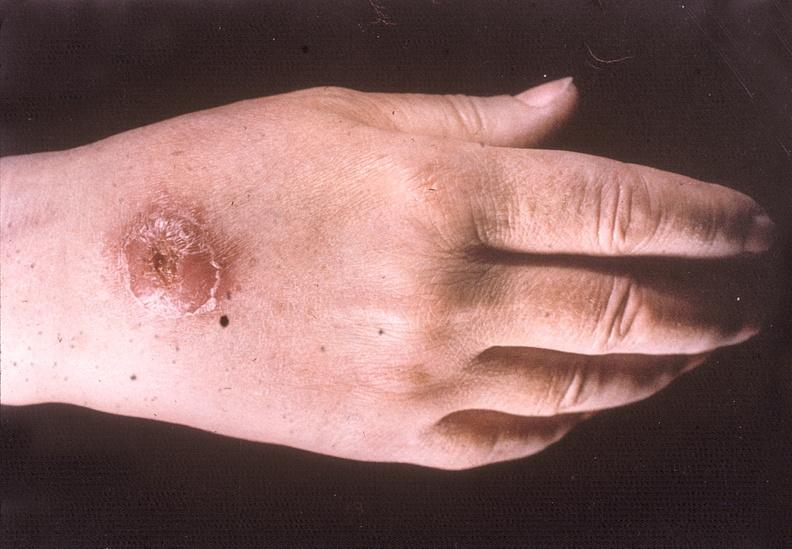what does this image show?
Answer the question using a single word or phrase. Hand 